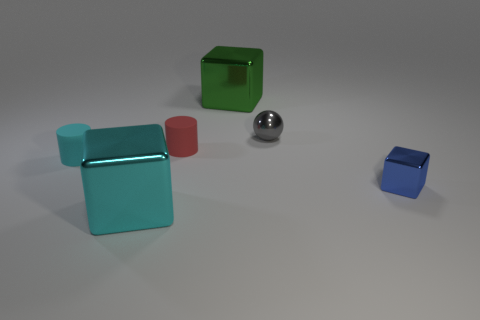Add 1 tiny blue matte spheres. How many objects exist? 7 Subtract all cylinders. How many objects are left? 4 Subtract 1 gray balls. How many objects are left? 5 Subtract all tiny blue metal objects. Subtract all big brown metallic things. How many objects are left? 5 Add 2 small red matte things. How many small red matte things are left? 3 Add 3 brown metallic balls. How many brown metallic balls exist? 3 